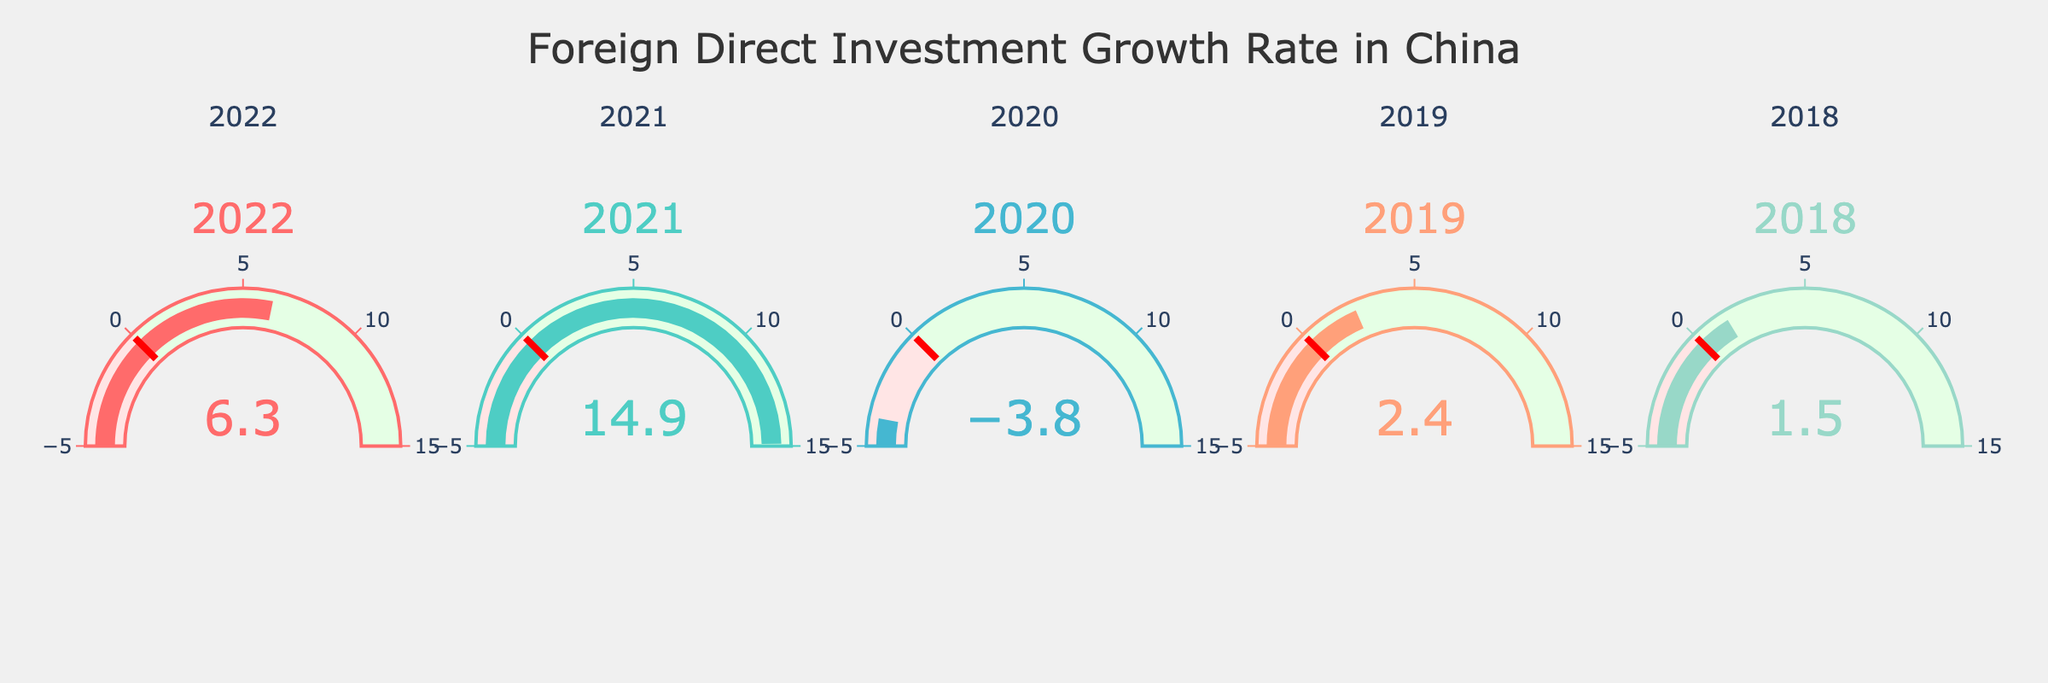What's the title of the figure? The title is displayed at the top center of the figure. It reads, "Foreign Direct Investment Growth Rate in China".
Answer: Foreign Direct Investment Growth Rate in China How many years of data are represented in the figure? The figure has a subplot for each year. Each subplot corresponds to a different year, which are listed as 2018, 2019, 2020, 2021, and 2022.
Answer: 5 Which year had the highest Foreign Direct Investment (FDI) growth rate? Looking at the numbers on the respective gauges for each year, 2021 shows the highest number among all years, indicating it had the highest FDI growth rate.
Answer: 2021 Was there any year with a negative FDI growth rate, and if so, which one? Examining the numbers on the gauges, 2020 has a negative number (-3.8), showing it had a negative FDI growth rate.
Answer: 2020 What's the average FDI growth rate over the given years? To calculate the average, add up all the FDI growth rates (6.3, 14.9, -3.8, 2.4, 1.5) and then divide by the number of years (5). The sum is 21.3, and dividing by 5 gives 21.3 / 5 = 4.26.
Answer: 4.26 Compare the FDI growth rate in 2022 and 2018. Which year had a higher rate? By inspecting the gauges of the two years, 2022 shows 6.3, and 2018 shows 1.5. Since 6.3 is greater than 1.5, 2022 had a higher FDI growth rate.
Answer: 2022 What is the difference in FDI growth rate between the year with the highest rate and the year with the lowest rate? The highest rate is in 2021 (14.9), and the lowest rate is in 2020 (-3.8). Subtracting the lowest from the highest, 14.9 - (-3.8), results in 14.9 + 3.8 = 18.7.
Answer: 18.7 By how much did the FDI growth rate increase from 2018 to 2019? The FDI growth rate in 2018 was 1.5, and in 2019 was 2.4. The increase is calculated by subtracting the 2018 rate from the 2019 rate, giving 2.4 - 1.5 = 0.9.
Answer: 0.9 